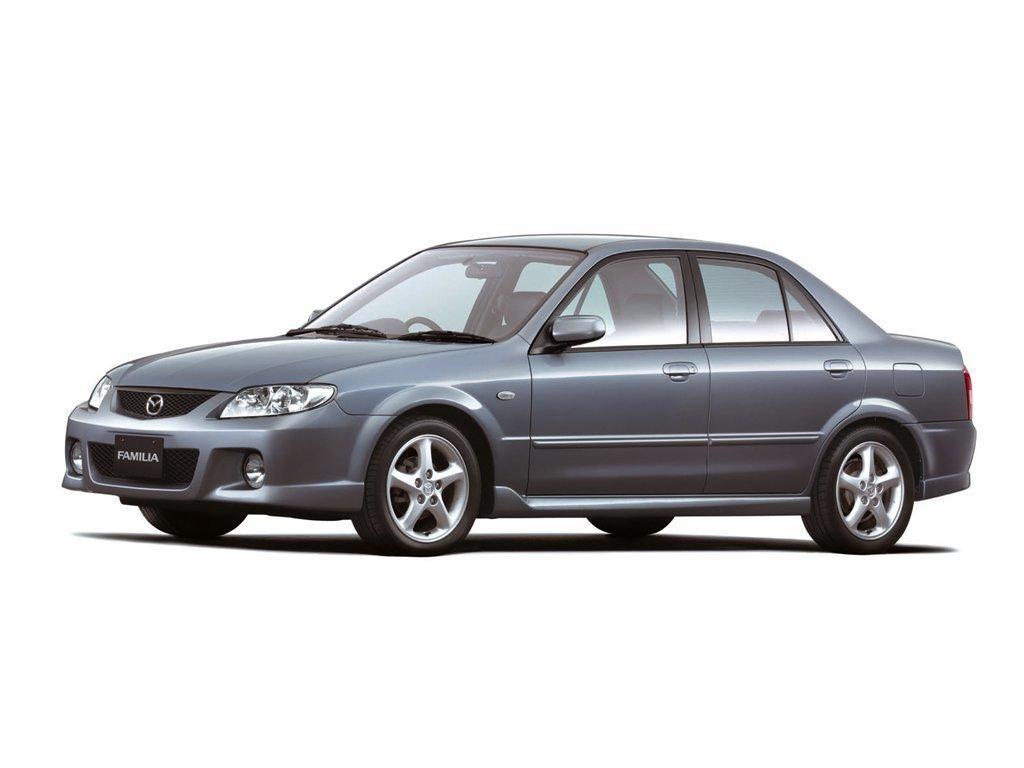Please provide a concise description of this image. In this image there is a picture of a car as we can see in the middle of this image. 